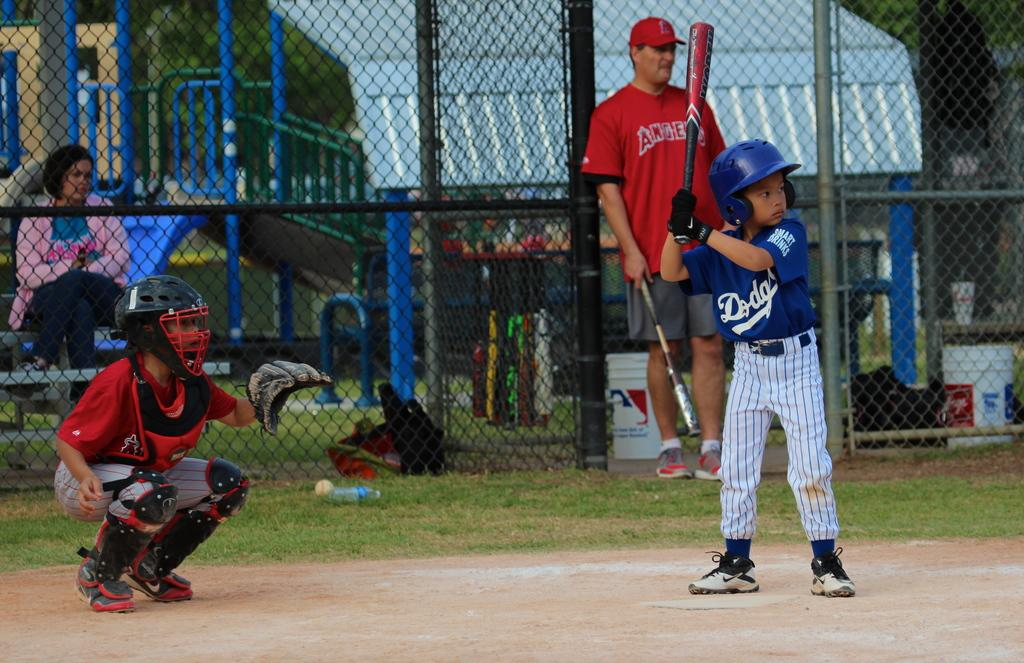<image>
Present a compact description of the photo's key features. A boy in a Dodgers baseball outfit gets ready to bat. 